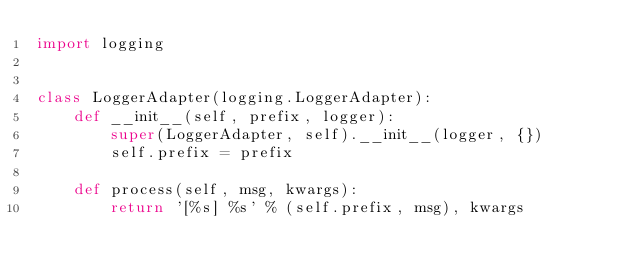<code> <loc_0><loc_0><loc_500><loc_500><_Python_>import logging


class LoggerAdapter(logging.LoggerAdapter):
    def __init__(self, prefix, logger):
        super(LoggerAdapter, self).__init__(logger, {})
        self.prefix = prefix

    def process(self, msg, kwargs):
        return '[%s] %s' % (self.prefix, msg), kwargs
</code> 